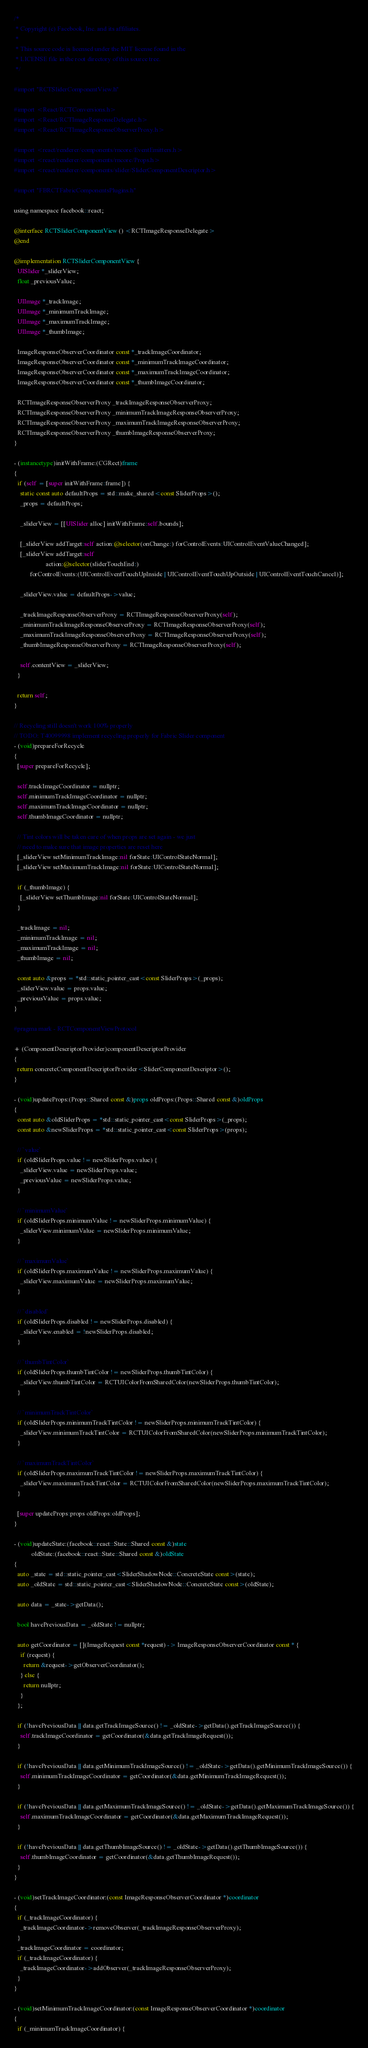Convert code to text. <code><loc_0><loc_0><loc_500><loc_500><_ObjectiveC_>/*
 * Copyright (c) Facebook, Inc. and its affiliates.
 *
 * This source code is licensed under the MIT license found in the
 * LICENSE file in the root directory of this source tree.
 */

#import "RCTSliderComponentView.h"

#import <React/RCTConversions.h>
#import <React/RCTImageResponseDelegate.h>
#import <React/RCTImageResponseObserverProxy.h>

#import <react/renderer/components/rncore/EventEmitters.h>
#import <react/renderer/components/rncore/Props.h>
#import <react/renderer/components/slider/SliderComponentDescriptor.h>

#import "FBRCTFabricComponentsPlugins.h"

using namespace facebook::react;

@interface RCTSliderComponentView () <RCTImageResponseDelegate>
@end

@implementation RCTSliderComponentView {
  UISlider *_sliderView;
  float _previousValue;

  UIImage *_trackImage;
  UIImage *_minimumTrackImage;
  UIImage *_maximumTrackImage;
  UIImage *_thumbImage;

  ImageResponseObserverCoordinator const *_trackImageCoordinator;
  ImageResponseObserverCoordinator const *_minimumTrackImageCoordinator;
  ImageResponseObserverCoordinator const *_maximumTrackImageCoordinator;
  ImageResponseObserverCoordinator const *_thumbImageCoordinator;

  RCTImageResponseObserverProxy _trackImageResponseObserverProxy;
  RCTImageResponseObserverProxy _minimumTrackImageResponseObserverProxy;
  RCTImageResponseObserverProxy _maximumTrackImageResponseObserverProxy;
  RCTImageResponseObserverProxy _thumbImageResponseObserverProxy;
}

- (instancetype)initWithFrame:(CGRect)frame
{
  if (self = [super initWithFrame:frame]) {
    static const auto defaultProps = std::make_shared<const SliderProps>();
    _props = defaultProps;

    _sliderView = [[UISlider alloc] initWithFrame:self.bounds];

    [_sliderView addTarget:self action:@selector(onChange:) forControlEvents:UIControlEventValueChanged];
    [_sliderView addTarget:self
                    action:@selector(sliderTouchEnd:)
          forControlEvents:(UIControlEventTouchUpInside | UIControlEventTouchUpOutside | UIControlEventTouchCancel)];

    _sliderView.value = defaultProps->value;

    _trackImageResponseObserverProxy = RCTImageResponseObserverProxy(self);
    _minimumTrackImageResponseObserverProxy = RCTImageResponseObserverProxy(self);
    _maximumTrackImageResponseObserverProxy = RCTImageResponseObserverProxy(self);
    _thumbImageResponseObserverProxy = RCTImageResponseObserverProxy(self);

    self.contentView = _sliderView;
  }

  return self;
}

// Recycling still doesn't work 100% properly
// TODO: T40099998 implement recycling properly for Fabric Slider component
- (void)prepareForRecycle
{
  [super prepareForRecycle];

  self.trackImageCoordinator = nullptr;
  self.minimumTrackImageCoordinator = nullptr;
  self.maximumTrackImageCoordinator = nullptr;
  self.thumbImageCoordinator = nullptr;

  // Tint colors will be taken care of when props are set again - we just
  // need to make sure that image properties are reset here
  [_sliderView setMinimumTrackImage:nil forState:UIControlStateNormal];
  [_sliderView setMaximumTrackImage:nil forState:UIControlStateNormal];

  if (_thumbImage) {
    [_sliderView setThumbImage:nil forState:UIControlStateNormal];
  }

  _trackImage = nil;
  _minimumTrackImage = nil;
  _maximumTrackImage = nil;
  _thumbImage = nil;

  const auto &props = *std::static_pointer_cast<const SliderProps>(_props);
  _sliderView.value = props.value;
  _previousValue = props.value;
}

#pragma mark - RCTComponentViewProtocol

+ (ComponentDescriptorProvider)componentDescriptorProvider
{
  return concreteComponentDescriptorProvider<SliderComponentDescriptor>();
}

- (void)updateProps:(Props::Shared const &)props oldProps:(Props::Shared const &)oldProps
{
  const auto &oldSliderProps = *std::static_pointer_cast<const SliderProps>(_props);
  const auto &newSliderProps = *std::static_pointer_cast<const SliderProps>(props);

  // `value`
  if (oldSliderProps.value != newSliderProps.value) {
    _sliderView.value = newSliderProps.value;
    _previousValue = newSliderProps.value;
  }

  // `minimumValue`
  if (oldSliderProps.minimumValue != newSliderProps.minimumValue) {
    _sliderView.minimumValue = newSliderProps.minimumValue;
  }

  // `maximumValue`
  if (oldSliderProps.maximumValue != newSliderProps.maximumValue) {
    _sliderView.maximumValue = newSliderProps.maximumValue;
  }

  // `disabled`
  if (oldSliderProps.disabled != newSliderProps.disabled) {
    _sliderView.enabled = !newSliderProps.disabled;
  }

  // `thumbTintColor`
  if (oldSliderProps.thumbTintColor != newSliderProps.thumbTintColor) {
    _sliderView.thumbTintColor = RCTUIColorFromSharedColor(newSliderProps.thumbTintColor);
  }

  // `minimumTrackTintColor`
  if (oldSliderProps.minimumTrackTintColor != newSliderProps.minimumTrackTintColor) {
    _sliderView.minimumTrackTintColor = RCTUIColorFromSharedColor(newSliderProps.minimumTrackTintColor);
  }

  // `maximumTrackTintColor`
  if (oldSliderProps.maximumTrackTintColor != newSliderProps.maximumTrackTintColor) {
    _sliderView.maximumTrackTintColor = RCTUIColorFromSharedColor(newSliderProps.maximumTrackTintColor);
  }

  [super updateProps:props oldProps:oldProps];
}

- (void)updateState:(facebook::react::State::Shared const &)state
           oldState:(facebook::react::State::Shared const &)oldState
{
  auto _state = std::static_pointer_cast<SliderShadowNode::ConcreteState const>(state);
  auto _oldState = std::static_pointer_cast<SliderShadowNode::ConcreteState const>(oldState);

  auto data = _state->getData();

  bool havePreviousData = _oldState != nullptr;

  auto getCoordinator = [](ImageRequest const *request) -> ImageResponseObserverCoordinator const * {
    if (request) {
      return &request->getObserverCoordinator();
    } else {
      return nullptr;
    }
  };

  if (!havePreviousData || data.getTrackImageSource() != _oldState->getData().getTrackImageSource()) {
    self.trackImageCoordinator = getCoordinator(&data.getTrackImageRequest());
  }

  if (!havePreviousData || data.getMinimumTrackImageSource() != _oldState->getData().getMinimumTrackImageSource()) {
    self.minimumTrackImageCoordinator = getCoordinator(&data.getMinimumTrackImageRequest());
  }

  if (!havePreviousData || data.getMaximumTrackImageSource() != _oldState->getData().getMaximumTrackImageSource()) {
    self.maximumTrackImageCoordinator = getCoordinator(&data.getMaximumTrackImageRequest());
  }

  if (!havePreviousData || data.getThumbImageSource() != _oldState->getData().getThumbImageSource()) {
    self.thumbImageCoordinator = getCoordinator(&data.getThumbImageRequest());
  }
}

- (void)setTrackImageCoordinator:(const ImageResponseObserverCoordinator *)coordinator
{
  if (_trackImageCoordinator) {
    _trackImageCoordinator->removeObserver(_trackImageResponseObserverProxy);
  }
  _trackImageCoordinator = coordinator;
  if (_trackImageCoordinator) {
    _trackImageCoordinator->addObserver(_trackImageResponseObserverProxy);
  }
}

- (void)setMinimumTrackImageCoordinator:(const ImageResponseObserverCoordinator *)coordinator
{
  if (_minimumTrackImageCoordinator) {</code> 